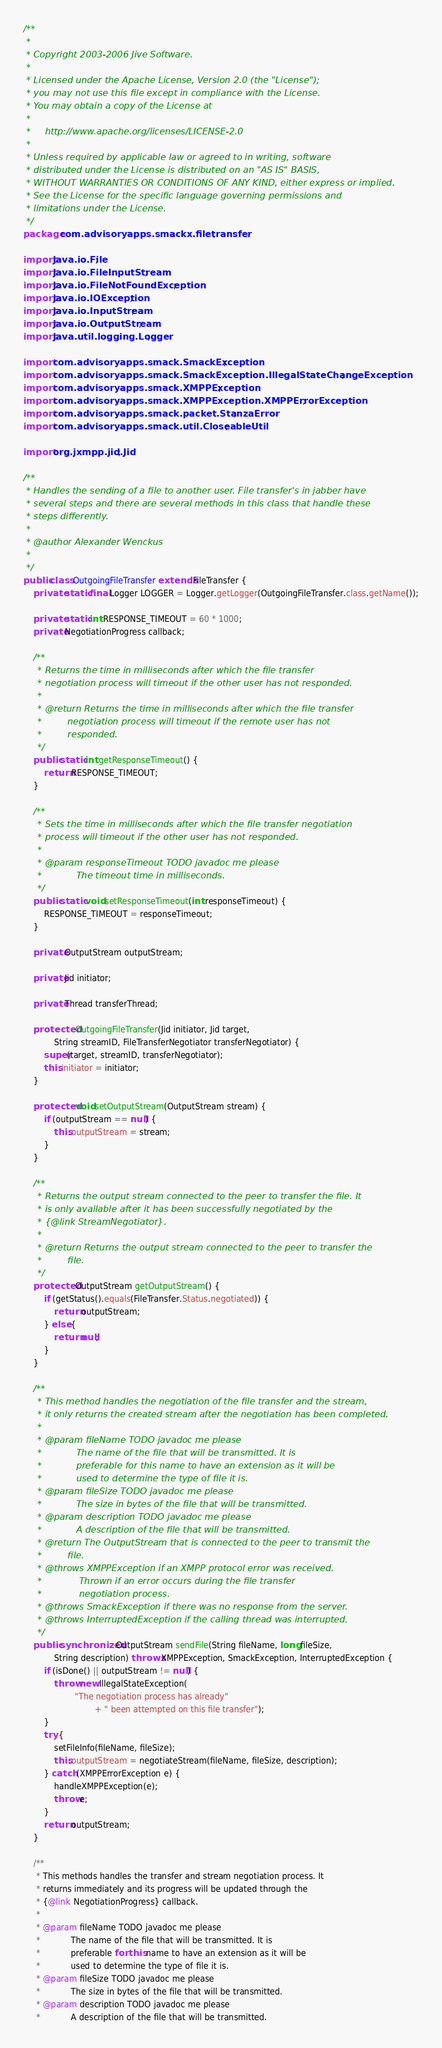<code> <loc_0><loc_0><loc_500><loc_500><_Java_>/**
 *
 * Copyright 2003-2006 Jive Software.
 *
 * Licensed under the Apache License, Version 2.0 (the "License");
 * you may not use this file except in compliance with the License.
 * You may obtain a copy of the License at
 *
 *     http://www.apache.org/licenses/LICENSE-2.0
 *
 * Unless required by applicable law or agreed to in writing, software
 * distributed under the License is distributed on an "AS IS" BASIS,
 * WITHOUT WARRANTIES OR CONDITIONS OF ANY KIND, either express or implied.
 * See the License for the specific language governing permissions and
 * limitations under the License.
 */
package com.advisoryapps.smackx.filetransfer;

import java.io.File;
import java.io.FileInputStream;
import java.io.FileNotFoundException;
import java.io.IOException;
import java.io.InputStream;
import java.io.OutputStream;
import java.util.logging.Logger;

import com.advisoryapps.smack.SmackException;
import com.advisoryapps.smack.SmackException.IllegalStateChangeException;
import com.advisoryapps.smack.XMPPException;
import com.advisoryapps.smack.XMPPException.XMPPErrorException;
import com.advisoryapps.smack.packet.StanzaError;
import com.advisoryapps.smack.util.CloseableUtil;

import org.jxmpp.jid.Jid;

/**
 * Handles the sending of a file to another user. File transfer's in jabber have
 * several steps and there are several methods in this class that handle these
 * steps differently.
 *
 * @author Alexander Wenckus
 *
 */
public class OutgoingFileTransfer extends FileTransfer {
    private static final Logger LOGGER = Logger.getLogger(OutgoingFileTransfer.class.getName());

    private static int RESPONSE_TIMEOUT = 60 * 1000;
    private NegotiationProgress callback;

    /**
     * Returns the time in milliseconds after which the file transfer
     * negotiation process will timeout if the other user has not responded.
     *
     * @return Returns the time in milliseconds after which the file transfer
     *         negotiation process will timeout if the remote user has not
     *         responded.
     */
    public static int getResponseTimeout() {
        return RESPONSE_TIMEOUT;
    }

    /**
     * Sets the time in milliseconds after which the file transfer negotiation
     * process will timeout if the other user has not responded.
     *
     * @param responseTimeout TODO javadoc me please
     *            The timeout time in milliseconds.
     */
    public static void setResponseTimeout(int responseTimeout) {
        RESPONSE_TIMEOUT = responseTimeout;
    }

    private OutputStream outputStream;

    private Jid initiator;

    private Thread transferThread;

    protected OutgoingFileTransfer(Jid initiator, Jid target,
            String streamID, FileTransferNegotiator transferNegotiator) {
        super(target, streamID, transferNegotiator);
        this.initiator = initiator;
    }

    protected void setOutputStream(OutputStream stream) {
        if (outputStream == null) {
            this.outputStream = stream;
        }
    }

    /**
     * Returns the output stream connected to the peer to transfer the file. It
     * is only available after it has been successfully negotiated by the
     * {@link StreamNegotiator}.
     *
     * @return Returns the output stream connected to the peer to transfer the
     *         file.
     */
    protected OutputStream getOutputStream() {
        if (getStatus().equals(FileTransfer.Status.negotiated)) {
            return outputStream;
        } else {
            return null;
        }
    }

    /**
     * This method handles the negotiation of the file transfer and the stream,
     * it only returns the created stream after the negotiation has been completed.
     *
     * @param fileName TODO javadoc me please
     *            The name of the file that will be transmitted. It is
     *            preferable for this name to have an extension as it will be
     *            used to determine the type of file it is.
     * @param fileSize TODO javadoc me please
     *            The size in bytes of the file that will be transmitted.
     * @param description TODO javadoc me please
     *            A description of the file that will be transmitted.
     * @return The OutputStream that is connected to the peer to transmit the
     *         file.
     * @throws XMPPException if an XMPP protocol error was received.
     *             Thrown if an error occurs during the file transfer
     *             negotiation process.
     * @throws SmackException if there was no response from the server.
     * @throws InterruptedException if the calling thread was interrupted.
     */
    public synchronized OutputStream sendFile(String fileName, long fileSize,
            String description) throws XMPPException, SmackException, InterruptedException {
        if (isDone() || outputStream != null) {
            throw new IllegalStateException(
                    "The negotiation process has already"
                            + " been attempted on this file transfer");
        }
        try {
            setFileInfo(fileName, fileSize);
            this.outputStream = negotiateStream(fileName, fileSize, description);
        } catch (XMPPErrorException e) {
            handleXMPPException(e);
            throw e;
        }
        return outputStream;
    }

    /**
     * This methods handles the transfer and stream negotiation process. It
     * returns immediately and its progress will be updated through the
     * {@link NegotiationProgress} callback.
     *
     * @param fileName TODO javadoc me please
     *            The name of the file that will be transmitted. It is
     *            preferable for this name to have an extension as it will be
     *            used to determine the type of file it is.
     * @param fileSize TODO javadoc me please
     *            The size in bytes of the file that will be transmitted.
     * @param description TODO javadoc me please
     *            A description of the file that will be transmitted.</code> 